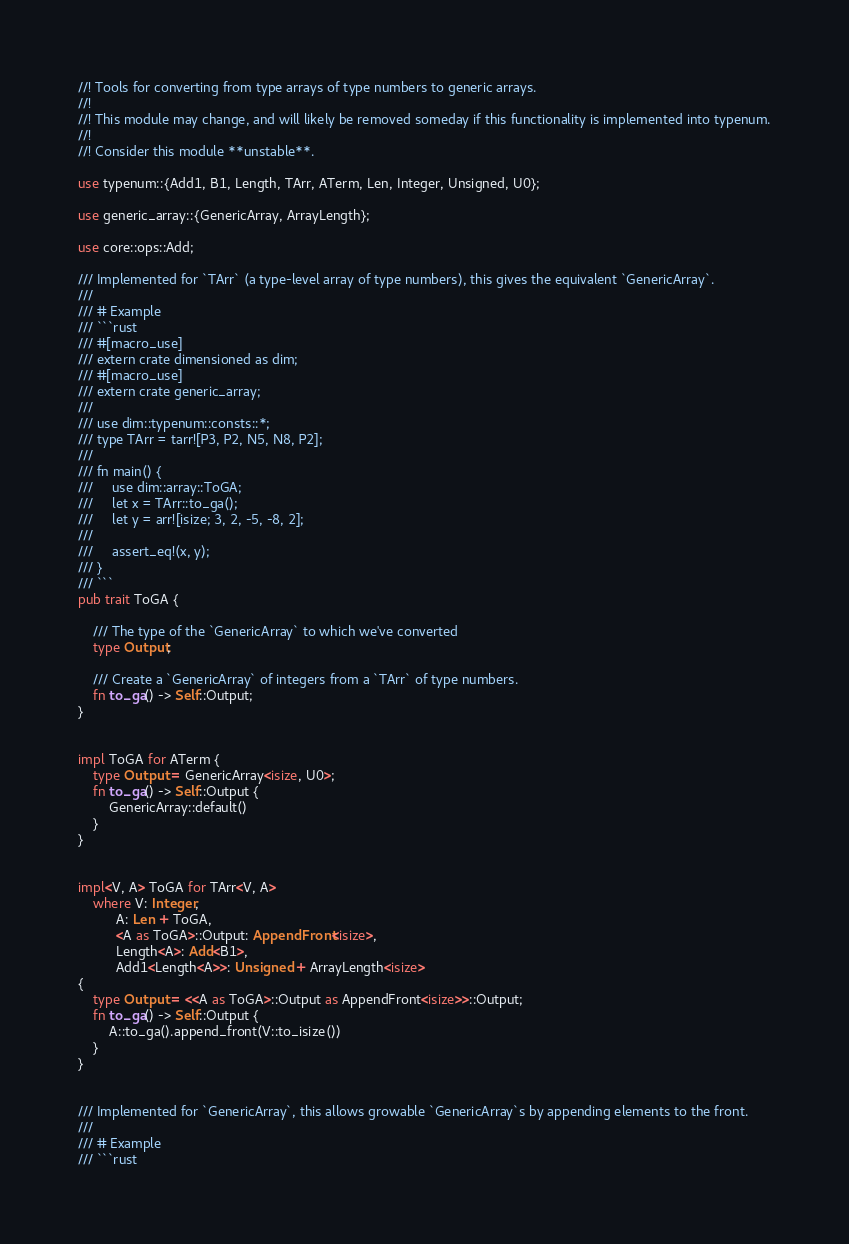<code> <loc_0><loc_0><loc_500><loc_500><_Rust_>//! Tools for converting from type arrays of type numbers to generic arrays.
//!
//! This module may change, and will likely be removed someday if this functionality is implemented into typenum.
//!
//! Consider this module **unstable**.

use typenum::{Add1, B1, Length, TArr, ATerm, Len, Integer, Unsigned, U0};

use generic_array::{GenericArray, ArrayLength};

use core::ops::Add;

/// Implemented for `TArr` (a type-level array of type numbers), this gives the equivalent `GenericArray`.
///
/// # Example
/// ```rust
/// #[macro_use]
/// extern crate dimensioned as dim;
/// #[macro_use]
/// extern crate generic_array;
///
/// use dim::typenum::consts::*;
/// type TArr = tarr![P3, P2, N5, N8, P2];
///
/// fn main() {
///     use dim::array::ToGA;
///     let x = TArr::to_ga();
///     let y = arr![isize; 3, 2, -5, -8, 2];
///
///     assert_eq!(x, y);
/// }
/// ```
pub trait ToGA {

    /// The type of the `GenericArray` to which we've converted
    type Output;

    /// Create a `GenericArray` of integers from a `TArr` of type numbers.
    fn to_ga() -> Self::Output;
}


impl ToGA for ATerm {
    type Output = GenericArray<isize, U0>;
    fn to_ga() -> Self::Output {
        GenericArray::default()
    }
}


impl<V, A> ToGA for TArr<V, A>
    where V: Integer,
          A: Len + ToGA,
          <A as ToGA>::Output: AppendFront<isize>,
          Length<A>: Add<B1>,
          Add1<Length<A>>: Unsigned + ArrayLength<isize>
{
    type Output = <<A as ToGA>::Output as AppendFront<isize>>::Output;
    fn to_ga() -> Self::Output {
        A::to_ga().append_front(V::to_isize())
    }
}


/// Implemented for `GenericArray`, this allows growable `GenericArray`s by appending elements to the front.
///
/// # Example
/// ```rust</code> 